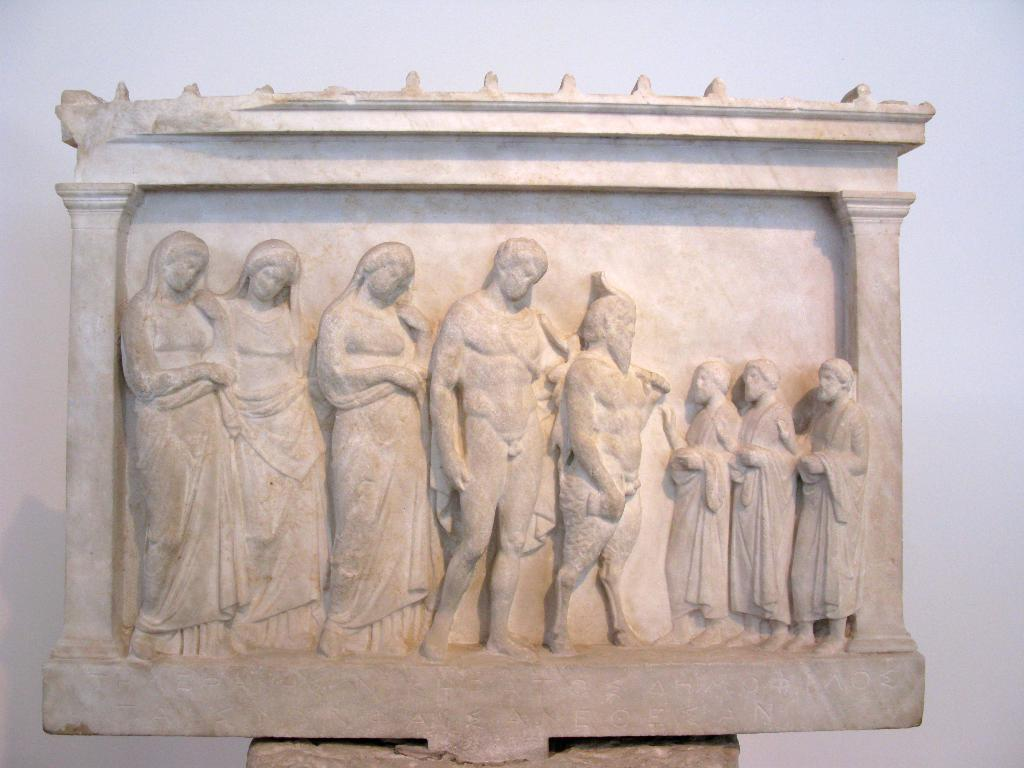What is the main subject in the image? There is a sculpture in the image. What else can be seen in the image besides the sculpture? There is a wall visible in the image. What type of ice can be seen melting on the sculpture in the image? There is no ice present on the sculpture in the image. 